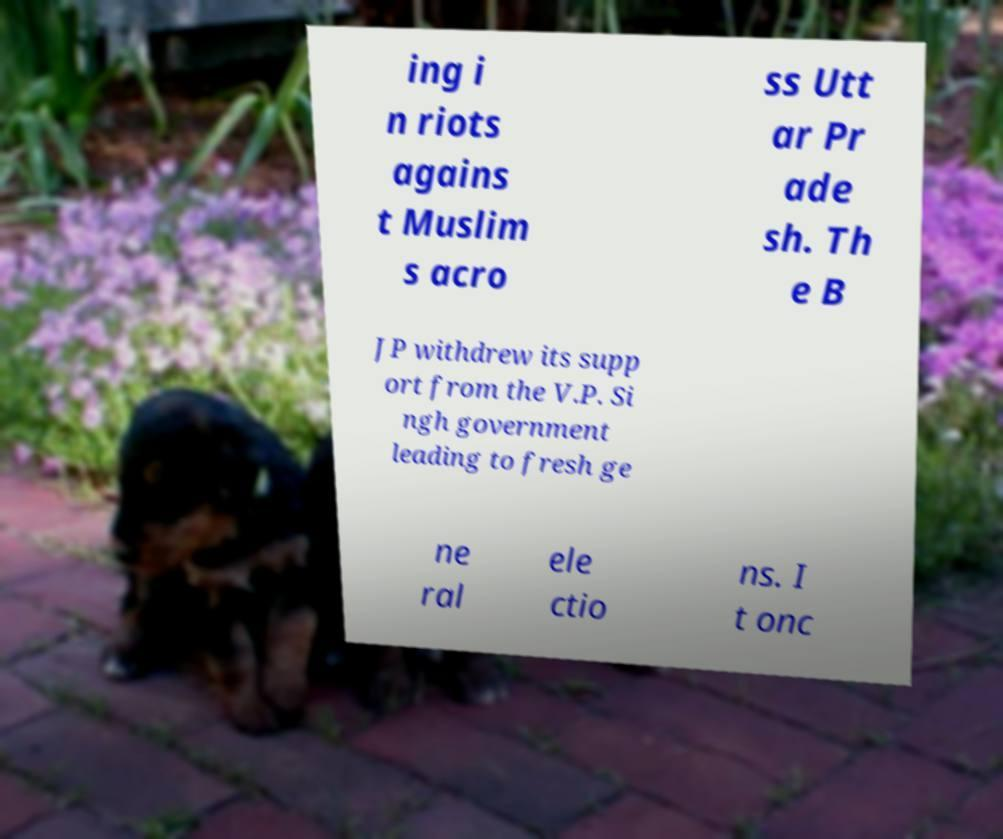Can you read and provide the text displayed in the image?This photo seems to have some interesting text. Can you extract and type it out for me? ing i n riots agains t Muslim s acro ss Utt ar Pr ade sh. Th e B JP withdrew its supp ort from the V.P. Si ngh government leading to fresh ge ne ral ele ctio ns. I t onc 